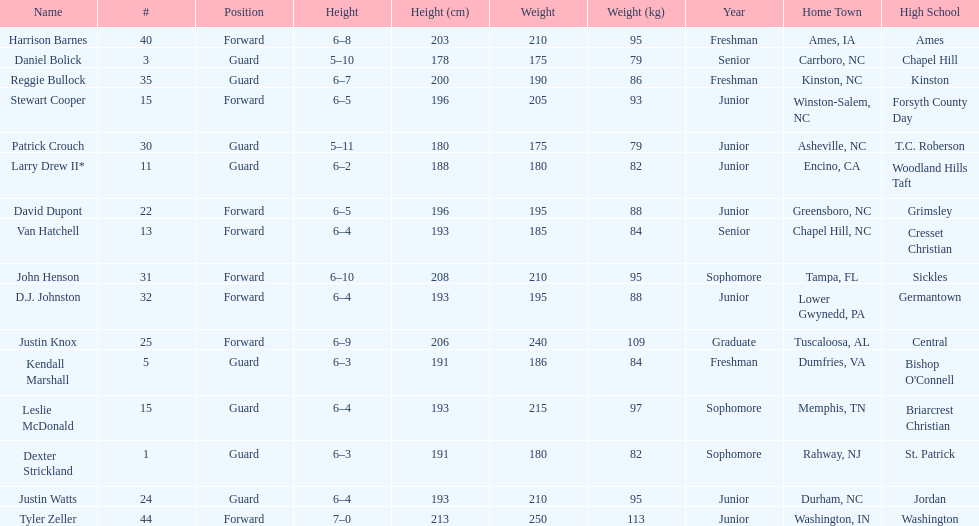Who was taller, justin knox or john henson? John Henson. 